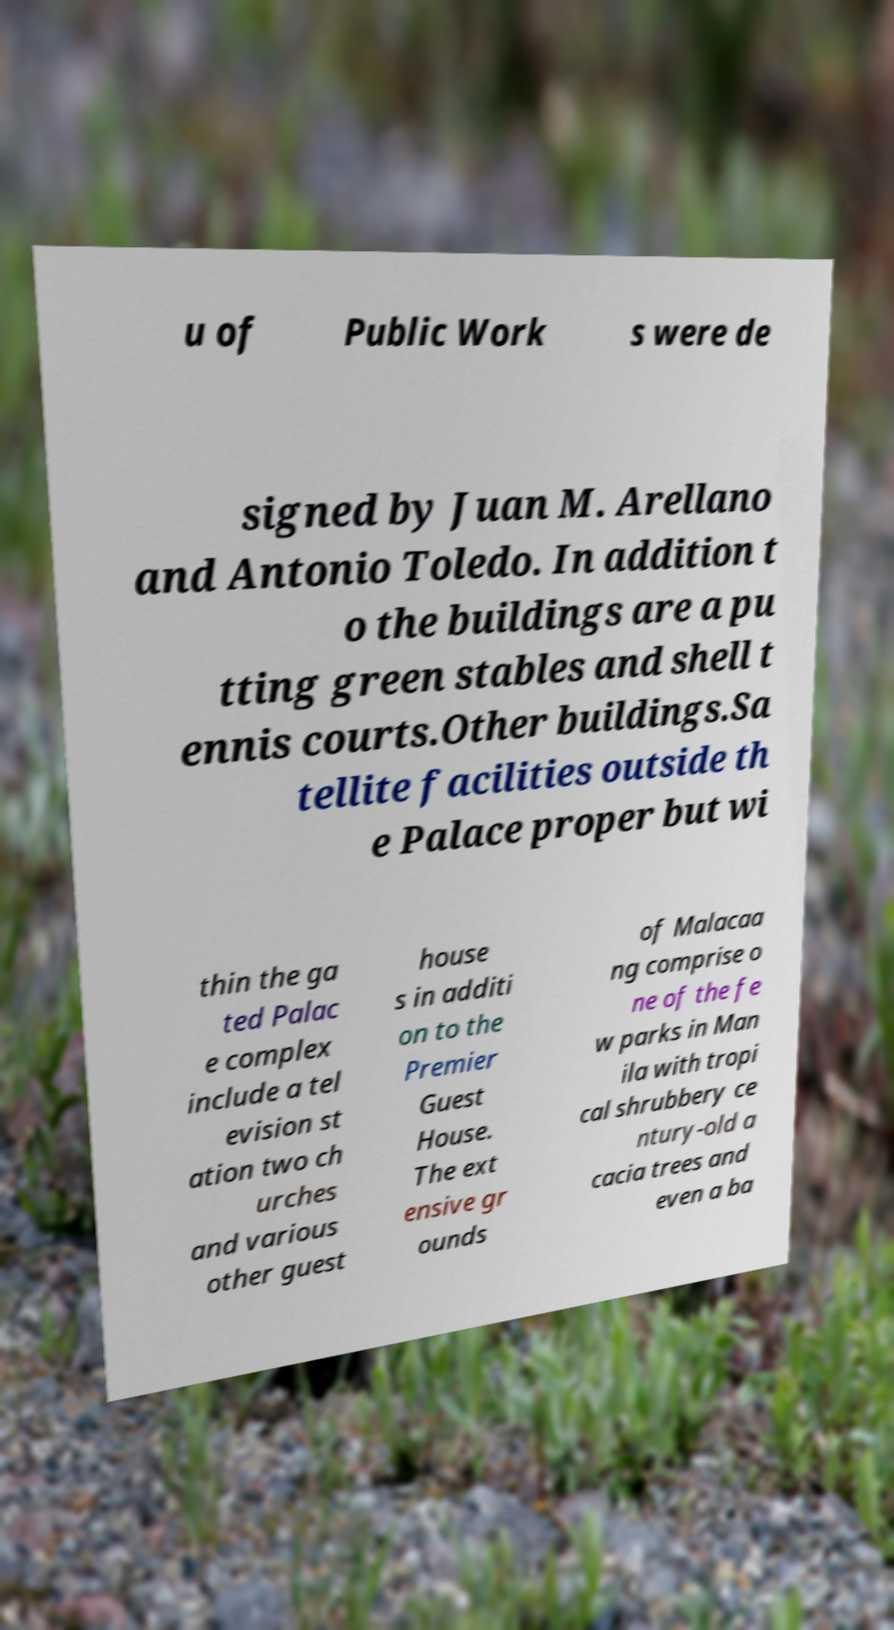I need the written content from this picture converted into text. Can you do that? u of Public Work s were de signed by Juan M. Arellano and Antonio Toledo. In addition t o the buildings are a pu tting green stables and shell t ennis courts.Other buildings.Sa tellite facilities outside th e Palace proper but wi thin the ga ted Palac e complex include a tel evision st ation two ch urches and various other guest house s in additi on to the Premier Guest House. The ext ensive gr ounds of Malacaa ng comprise o ne of the fe w parks in Man ila with tropi cal shrubbery ce ntury-old a cacia trees and even a ba 